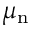<formula> <loc_0><loc_0><loc_500><loc_500>\mu _ { n }</formula> 